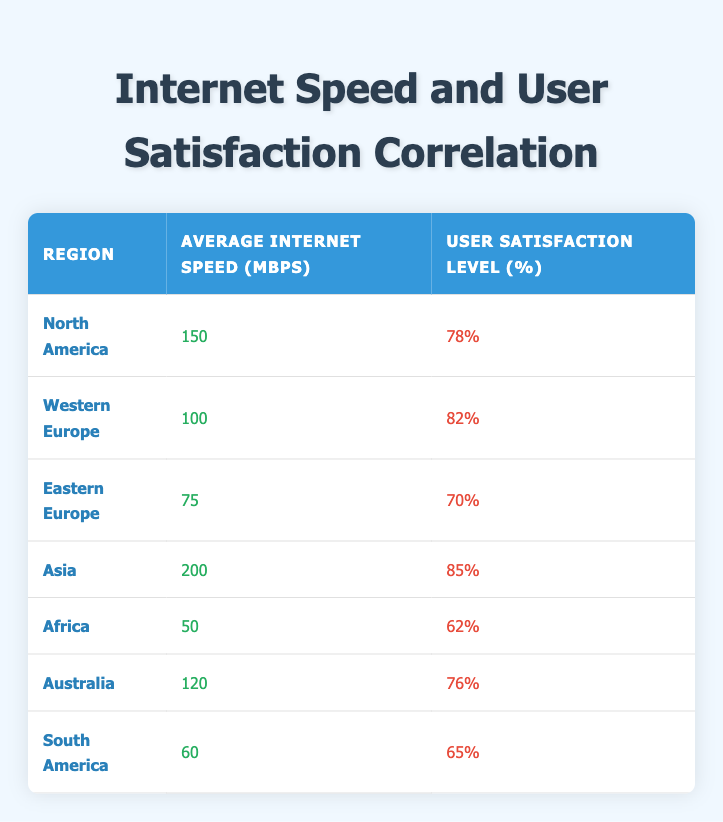What is the average internet speed in Asia? Looking at the table, the average internet speed listed for Asia is 200 Mbps. This value is taken directly from the "Average Internet Speed (Mbps)" column corresponding to Asia.
Answer: 200 Mbps What is the user satisfaction level in South America? From the table, the user satisfaction level for South America is 65%. This is found in the "User Satisfaction Level (%)" column for that region.
Answer: 65% Which region has the highest user satisfaction level? By examining the user satisfaction levels in the table, Asia has the highest user satisfaction level at 85%. This is the maximum value in the "User Satisfaction Level (%)" column.
Answer: Asia What is the difference in average internet speed between North America and Africa? To find this difference, we subtract Africa's average speed (50 Mbps) from North America's average speed (150 Mbps): 150 - 50 = 100 Mbps. This calculation uses the speeds specified in the "Average Internet Speed (Mbps)" column.
Answer: 100 Mbps Is it true that Western Europe has a higher user satisfaction level than North America? Comparing the values in the table, Western Europe has a user satisfaction level of 82% while North America has 78%. Since 82% is greater than 78%, the statement is true.
Answer: Yes Which region has the lowest average internet speed and what is that value? Looking at the table, Africa has the lowest average internet speed at 50 Mbps. This can be confirmed by comparing all values in the "Average Internet Speed (Mbps)" column.
Answer: 50 Mbps What is the average user satisfaction level of the regions listed? To find the average user satisfaction level, we sum the satisfaction levels (78 + 82 + 70 + 85 + 62 + 76 + 65) = 418 and then divide by the number of regions (7): 418/7 = 59.71%. Thus, the average user satisfaction level is approximately 71.14%.
Answer: 71.14% Does Asia have both the highest internet speed and the highest user satisfaction level? In the table, Asia does indeed have the highest average internet speed at 200 Mbps and the highest user satisfaction level at 85%. Therefore, both statements are true.
Answer: Yes 